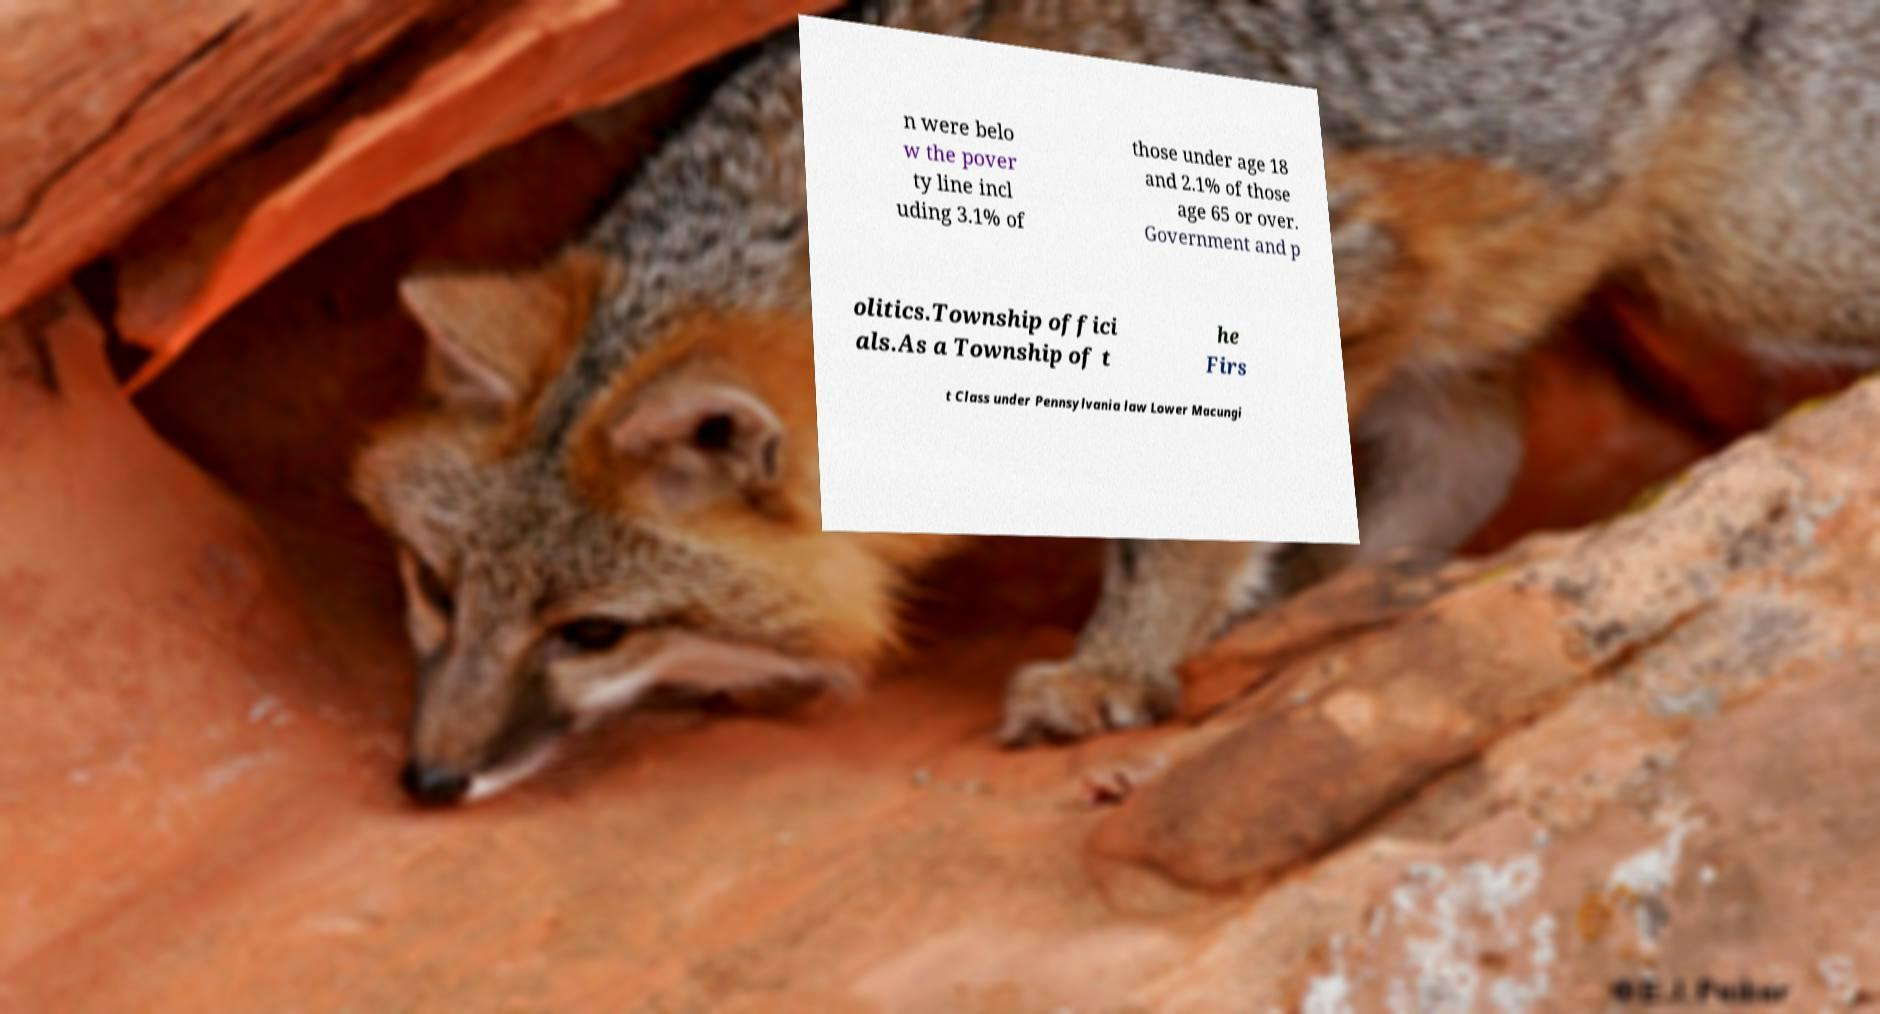What messages or text are displayed in this image? I need them in a readable, typed format. n were belo w the pover ty line incl uding 3.1% of those under age 18 and 2.1% of those age 65 or over. Government and p olitics.Township offici als.As a Township of t he Firs t Class under Pennsylvania law Lower Macungi 